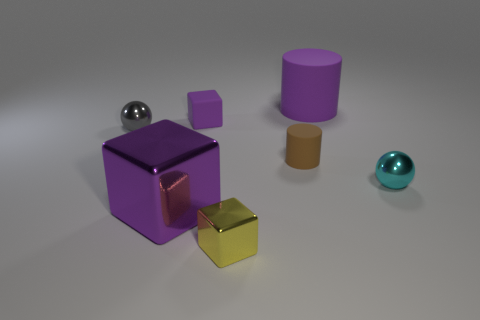Is the tiny yellow object made of the same material as the cyan object?
Keep it short and to the point. Yes. How big is the matte thing that is on the right side of the small purple matte thing and in front of the purple matte cylinder?
Offer a very short reply. Small. What is the shape of the small gray object?
Your answer should be very brief. Sphere. How many things are yellow shiny things or tiny things that are right of the big purple block?
Offer a very short reply. 4. There is a tiny thing that is behind the gray object; is its color the same as the tiny cylinder?
Give a very brief answer. No. What color is the matte object that is behind the small gray ball and on the right side of the small yellow cube?
Offer a terse response. Purple. There is a cylinder on the left side of the big matte cylinder; what is its material?
Make the answer very short. Rubber. What is the size of the purple rubber cube?
Your response must be concise. Small. What number of yellow objects are tiny metallic blocks or blocks?
Your answer should be compact. 1. There is a purple block behind the shiny ball that is to the right of the large block; how big is it?
Ensure brevity in your answer.  Small. 